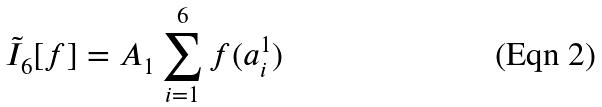Convert formula to latex. <formula><loc_0><loc_0><loc_500><loc_500>\tilde { I } _ { 6 } [ f ] = A _ { 1 } \sum _ { i = 1 } ^ { 6 } f ( a _ { i } ^ { 1 } )</formula> 